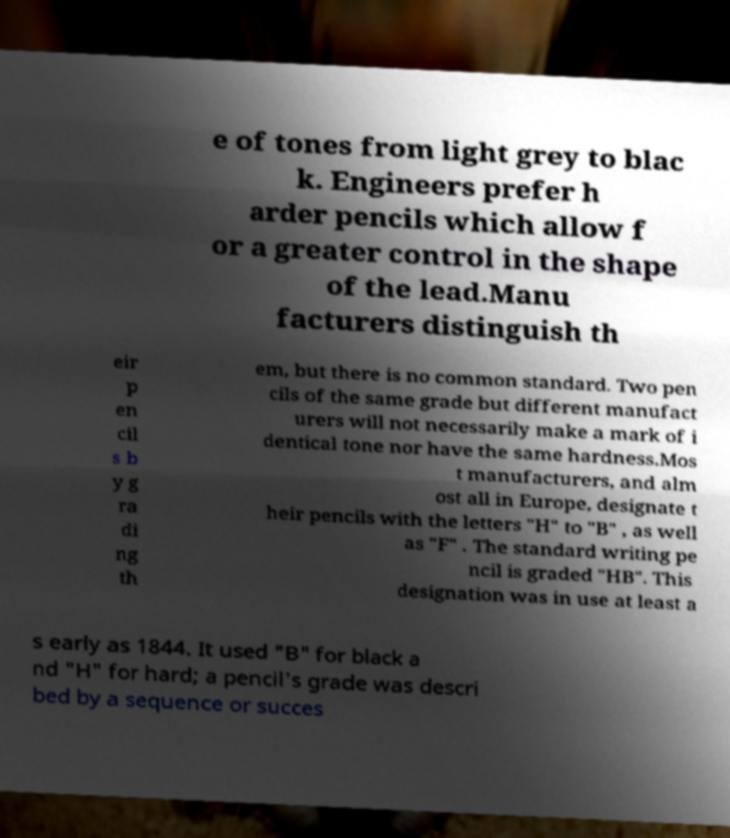For documentation purposes, I need the text within this image transcribed. Could you provide that? e of tones from light grey to blac k. Engineers prefer h arder pencils which allow f or a greater control in the shape of the lead.Manu facturers distinguish th eir p en cil s b y g ra di ng th em, but there is no common standard. Two pen cils of the same grade but different manufact urers will not necessarily make a mark of i dentical tone nor have the same hardness.Mos t manufacturers, and alm ost all in Europe, designate t heir pencils with the letters "H" to "B" , as well as "F" . The standard writing pe ncil is graded "HB". This designation was in use at least a s early as 1844. It used "B" for black a nd "H" for hard; a pencil's grade was descri bed by a sequence or succes 